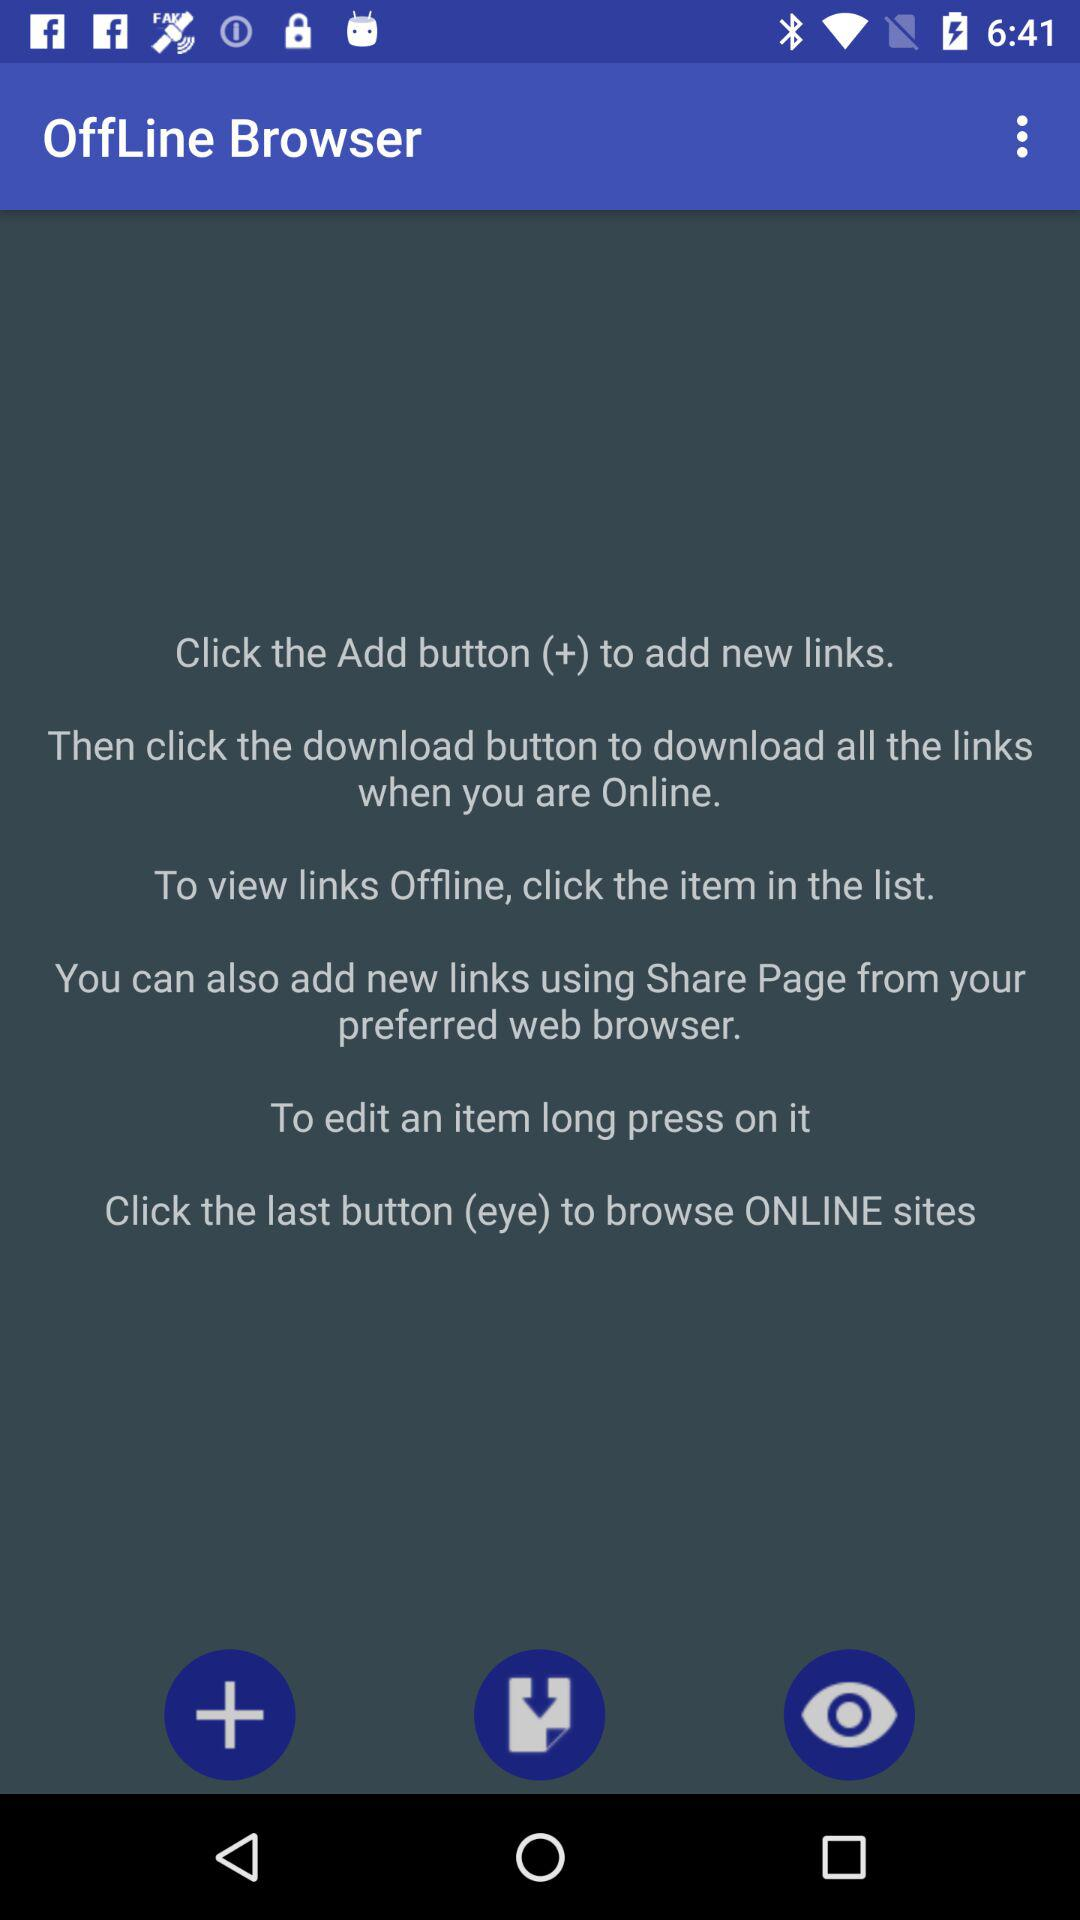When were "Offline Browser" links last downloaded?
When the provided information is insufficient, respond with <no answer>. <no answer> 